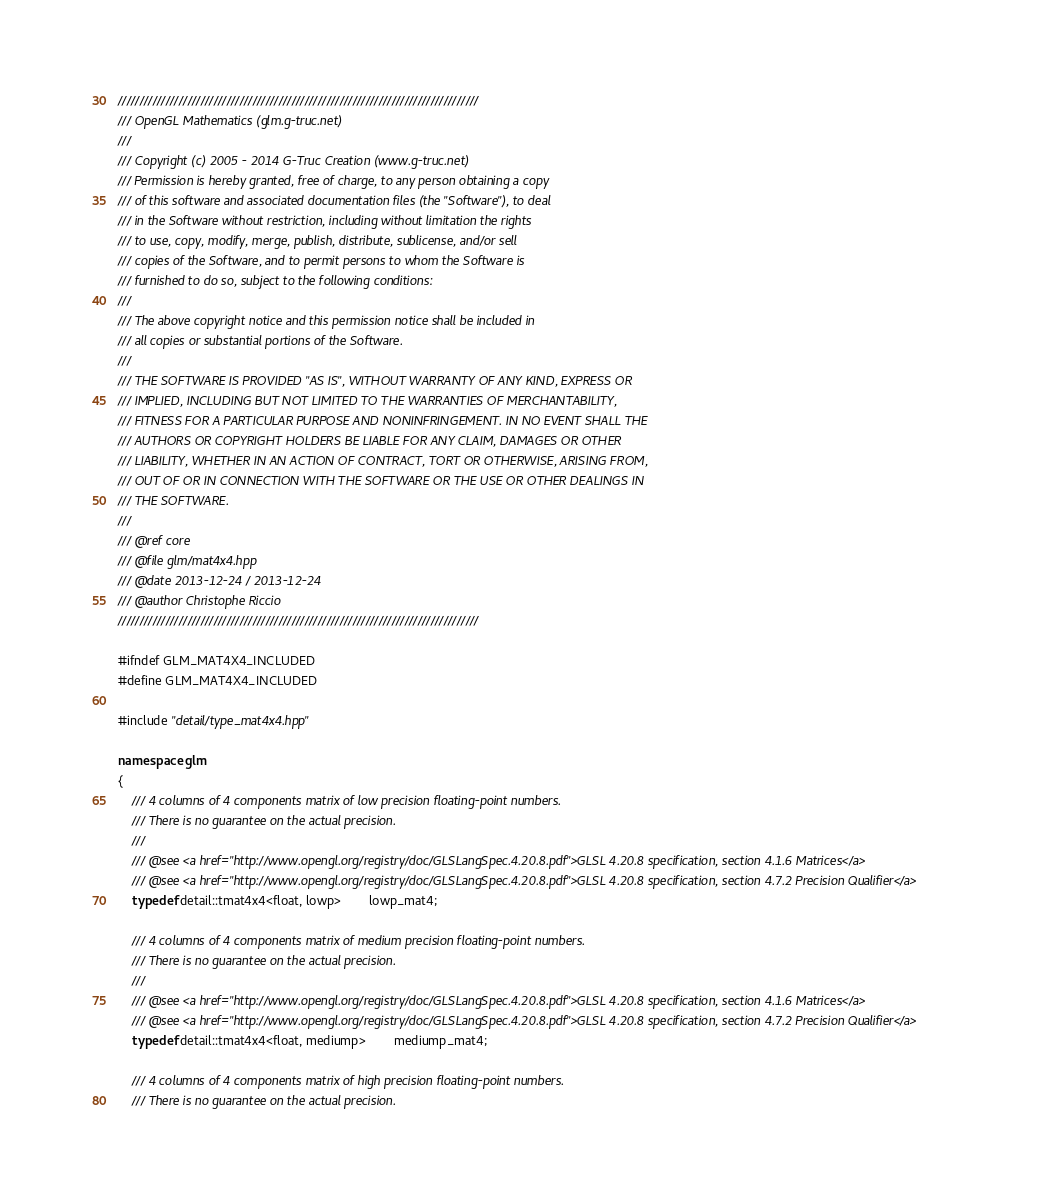<code> <loc_0><loc_0><loc_500><loc_500><_C++_>///////////////////////////////////////////////////////////////////////////////////
/// OpenGL Mathematics (glm.g-truc.net)
///
/// Copyright (c) 2005 - 2014 G-Truc Creation (www.g-truc.net)
/// Permission is hereby granted, free of charge, to any person obtaining a copy
/// of this software and associated documentation files (the "Software"), to deal
/// in the Software without restriction, including without limitation the rights
/// to use, copy, modify, merge, publish, distribute, sublicense, and/or sell
/// copies of the Software, and to permit persons to whom the Software is
/// furnished to do so, subject to the following conditions:
/// 
/// The above copyright notice and this permission notice shall be included in
/// all copies or substantial portions of the Software.
/// 
/// THE SOFTWARE IS PROVIDED "AS IS", WITHOUT WARRANTY OF ANY KIND, EXPRESS OR
/// IMPLIED, INCLUDING BUT NOT LIMITED TO THE WARRANTIES OF MERCHANTABILITY,
/// FITNESS FOR A PARTICULAR PURPOSE AND NONINFRINGEMENT. IN NO EVENT SHALL THE
/// AUTHORS OR COPYRIGHT HOLDERS BE LIABLE FOR ANY CLAIM, DAMAGES OR OTHER
/// LIABILITY, WHETHER IN AN ACTION OF CONTRACT, TORT OR OTHERWISE, ARISING FROM,
/// OUT OF OR IN CONNECTION WITH THE SOFTWARE OR THE USE OR OTHER DEALINGS IN
/// THE SOFTWARE.
///
/// @ref core
/// @file glm/mat4x4.hpp
/// @date 2013-12-24 / 2013-12-24
/// @author Christophe Riccio
///////////////////////////////////////////////////////////////////////////////////

#ifndef GLM_MAT4X4_INCLUDED
#define GLM_MAT4X4_INCLUDED

#include "detail/type_mat4x4.hpp"

namespace glm
{
	/// 4 columns of 4 components matrix of low precision floating-point numbers.
	/// There is no guarantee on the actual precision.
	///
	/// @see <a href="http://www.opengl.org/registry/doc/GLSLangSpec.4.20.8.pdf">GLSL 4.20.8 specification, section 4.1.6 Matrices</a>
	/// @see <a href="http://www.opengl.org/registry/doc/GLSLangSpec.4.20.8.pdf">GLSL 4.20.8 specification, section 4.7.2 Precision Qualifier</a>
	typedef detail::tmat4x4<float, lowp>		lowp_mat4;
	
	/// 4 columns of 4 components matrix of medium precision floating-point numbers.
	/// There is no guarantee on the actual precision.
	///
	/// @see <a href="http://www.opengl.org/registry/doc/GLSLangSpec.4.20.8.pdf">GLSL 4.20.8 specification, section 4.1.6 Matrices</a>
	/// @see <a href="http://www.opengl.org/registry/doc/GLSLangSpec.4.20.8.pdf">GLSL 4.20.8 specification, section 4.7.2 Precision Qualifier</a>
	typedef detail::tmat4x4<float, mediump>		mediump_mat4;
	
	/// 4 columns of 4 components matrix of high precision floating-point numbers.
	/// There is no guarantee on the actual precision.</code> 